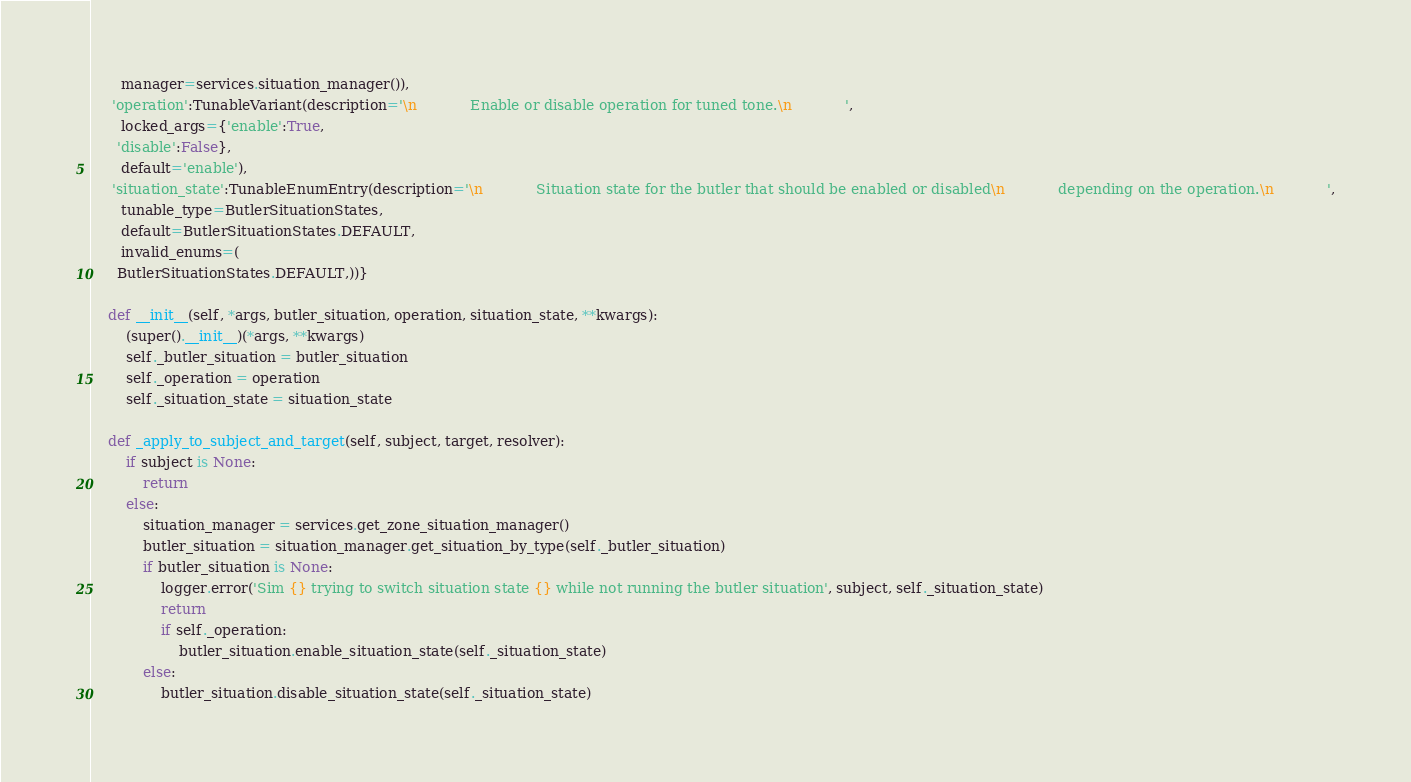Convert code to text. <code><loc_0><loc_0><loc_500><loc_500><_Python_>       manager=services.situation_manager()), 
     'operation':TunableVariant(description='\n            Enable or disable operation for tuned tone.\n            ',
       locked_args={'enable':True, 
      'disable':False},
       default='enable'), 
     'situation_state':TunableEnumEntry(description='\n            Situation state for the butler that should be enabled or disabled\n            depending on the operation.\n            ',
       tunable_type=ButlerSituationStates,
       default=ButlerSituationStates.DEFAULT,
       invalid_enums=(
      ButlerSituationStates.DEFAULT,))}

    def __init__(self, *args, butler_situation, operation, situation_state, **kwargs):
        (super().__init__)(*args, **kwargs)
        self._butler_situation = butler_situation
        self._operation = operation
        self._situation_state = situation_state

    def _apply_to_subject_and_target(self, subject, target, resolver):
        if subject is None:
            return
        else:
            situation_manager = services.get_zone_situation_manager()
            butler_situation = situation_manager.get_situation_by_type(self._butler_situation)
            if butler_situation is None:
                logger.error('Sim {} trying to switch situation state {} while not running the butler situation', subject, self._situation_state)
                return
                if self._operation:
                    butler_situation.enable_situation_state(self._situation_state)
            else:
                butler_situation.disable_situation_state(self._situation_state)</code> 